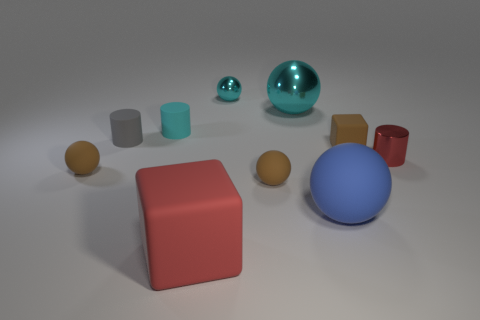Which objects in the image appears to be the most reflective? The most reflective objects in the image are the two balls. The smaller turquoise blue ball has a high gloss finish making it highly reflective, and the larger blue ball also has a reflective surface but with a slightly less intense sheen. 